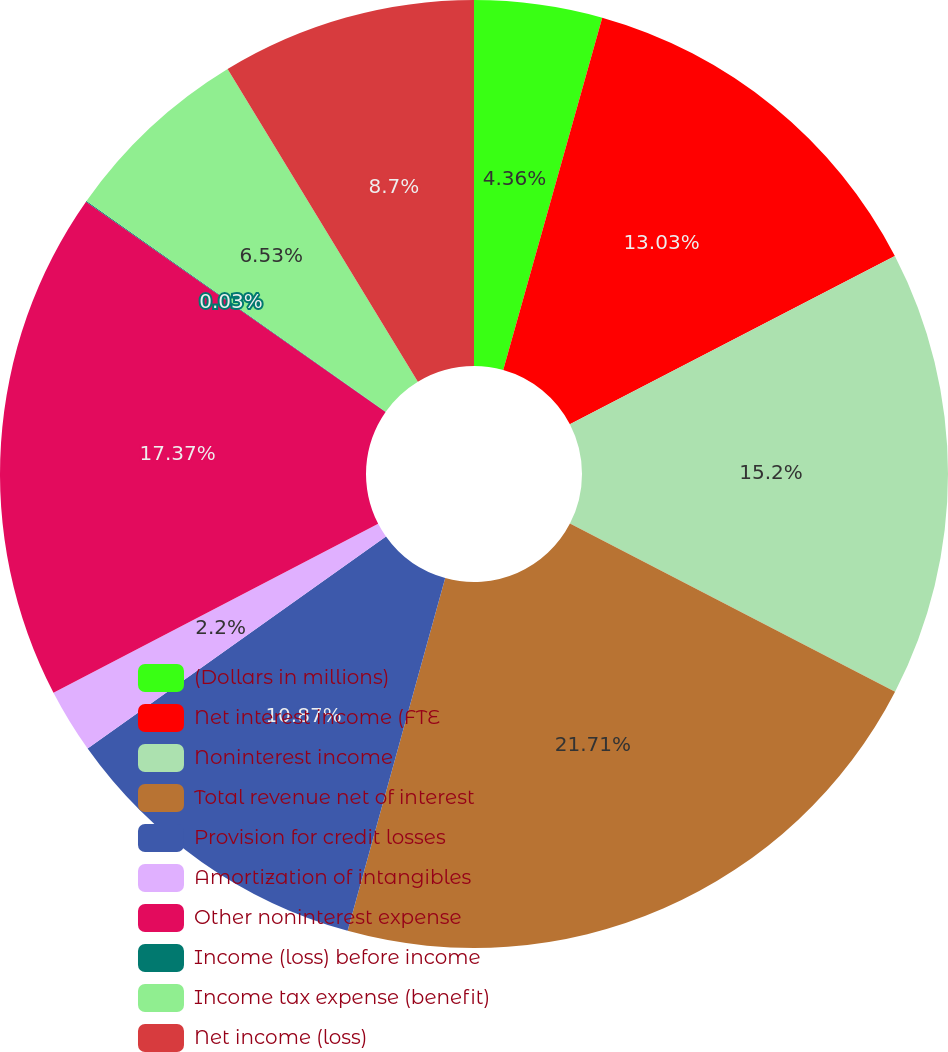Convert chart to OTSL. <chart><loc_0><loc_0><loc_500><loc_500><pie_chart><fcel>(Dollars in millions)<fcel>Net interest income (FTE<fcel>Noninterest income<fcel>Total revenue net of interest<fcel>Provision for credit losses<fcel>Amortization of intangibles<fcel>Other noninterest expense<fcel>Income (loss) before income<fcel>Income tax expense (benefit)<fcel>Net income (loss)<nl><fcel>4.36%<fcel>13.03%<fcel>15.2%<fcel>21.7%<fcel>10.87%<fcel>2.2%<fcel>17.37%<fcel>0.03%<fcel>6.53%<fcel>8.7%<nl></chart> 